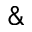<formula> <loc_0><loc_0><loc_500><loc_500>\&</formula> 